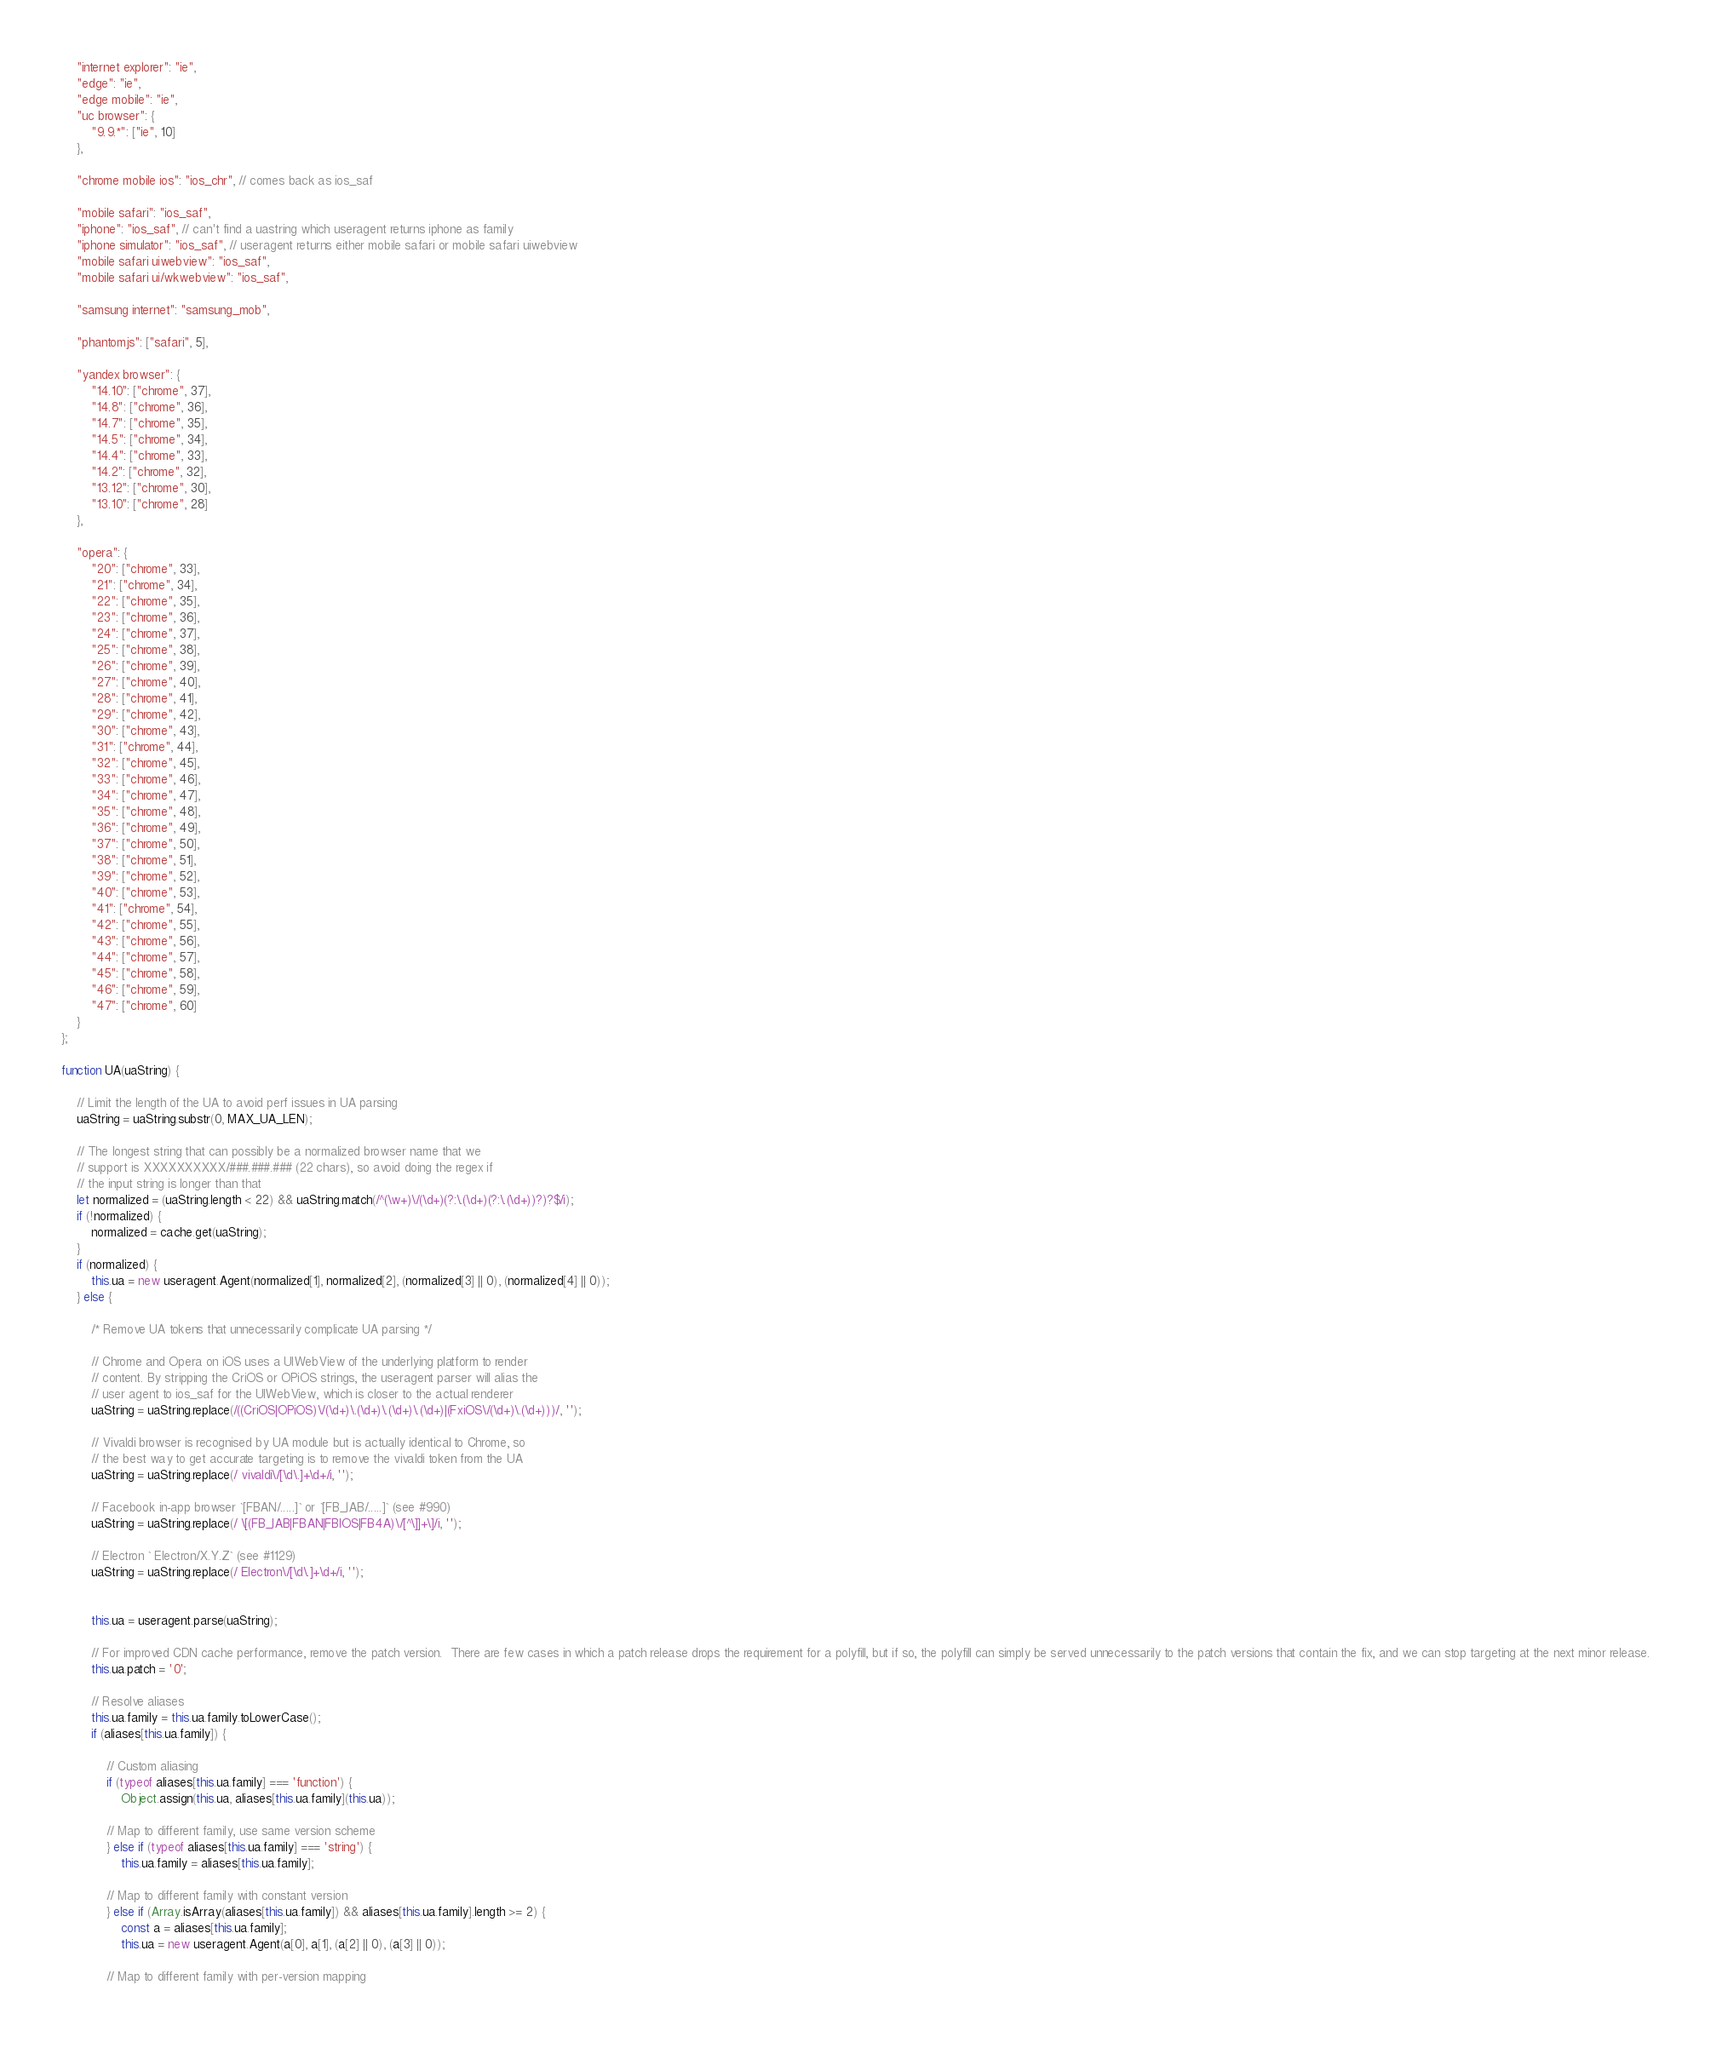<code> <loc_0><loc_0><loc_500><loc_500><_JavaScript_>	"internet explorer": "ie",
	"edge": "ie",
	"edge mobile": "ie",
	"uc browser": {
		"9.9.*": ["ie", 10]
	},

	"chrome mobile ios": "ios_chr", // comes back as ios_saf

	"mobile safari": "ios_saf",
	"iphone": "ios_saf", // can't find a uastring which useragent returns iphone as family
	"iphone simulator": "ios_saf", // useragent returns either mobile safari or mobile safari uiwebview
	"mobile safari uiwebview": "ios_saf",
	"mobile safari ui/wkwebview": "ios_saf",

	"samsung internet": "samsung_mob",

	"phantomjs": ["safari", 5],

	"yandex browser": {
		"14.10": ["chrome", 37],
		"14.8": ["chrome", 36],
		"14.7": ["chrome", 35],
		"14.5": ["chrome", 34],
		"14.4": ["chrome", 33],
		"14.2": ["chrome", 32],
		"13.12": ["chrome", 30],
		"13.10": ["chrome", 28]
	},

	"opera": {
		"20": ["chrome", 33],
		"21": ["chrome", 34],
		"22": ["chrome", 35],
		"23": ["chrome", 36],
		"24": ["chrome", 37],
		"25": ["chrome", 38],
		"26": ["chrome", 39],
		"27": ["chrome", 40],
		"28": ["chrome", 41],
		"29": ["chrome", 42],
		"30": ["chrome", 43],
		"31": ["chrome", 44],
		"32": ["chrome", 45],
		"33": ["chrome", 46],
		"34": ["chrome", 47],
		"35": ["chrome", 48],
		"36": ["chrome", 49],
		"37": ["chrome", 50],
		"38": ["chrome", 51],
		"39": ["chrome", 52],
		"40": ["chrome", 53],
		"41": ["chrome", 54],
		"42": ["chrome", 55],
		"43": ["chrome", 56],
		"44": ["chrome", 57],
		"45": ["chrome", 58],
		"46": ["chrome", 59],
		"47": ["chrome", 60]
	}
};

function UA(uaString) {

	// Limit the length of the UA to avoid perf issues in UA parsing
	uaString = uaString.substr(0, MAX_UA_LEN);

	// The longest string that can possibly be a normalized browser name that we
	// support is XXXXXXXXXX/###.###.### (22 chars), so avoid doing the regex if
	// the input string is longer than that
	let normalized = (uaString.length < 22) && uaString.match(/^(\w+)\/(\d+)(?:\.(\d+)(?:\.(\d+))?)?$/i);
	if (!normalized) {
		normalized = cache.get(uaString);
	}
	if (normalized) {
		this.ua = new useragent.Agent(normalized[1], normalized[2], (normalized[3] || 0), (normalized[4] || 0));
	} else {

		/* Remove UA tokens that unnecessarily complicate UA parsing */

		// Chrome and Opera on iOS uses a UIWebView of the underlying platform to render
		// content. By stripping the CriOS or OPiOS strings, the useragent parser will alias the
		// user agent to ios_saf for the UIWebView, which is closer to the actual renderer
		uaString = uaString.replace(/((CriOS|OPiOS)\/(\d+)\.(\d+)\.(\d+)\.(\d+)|(FxiOS\/(\d+)\.(\d+)))/, '');

		// Vivaldi browser is recognised by UA module but is actually identical to Chrome, so
		// the best way to get accurate targeting is to remove the vivaldi token from the UA
		uaString = uaString.replace(/ vivaldi\/[\d\.]+\d+/i, '');

		// Facebook in-app browser `[FBAN/.....]` or `[FB_IAB/.....]` (see #990)
		uaString = uaString.replace(/ \[(FB_IAB|FBAN|FBIOS|FB4A)\/[^\]]+\]/i, '');

		// Electron ` Electron/X.Y.Z` (see #1129)
		uaString = uaString.replace(/ Electron\/[\d\.]+\d+/i, '');


		this.ua = useragent.parse(uaString);

		// For improved CDN cache performance, remove the patch version.  There are few cases in which a patch release drops the requirement for a polyfill, but if so, the polyfill can simply be served unnecessarily to the patch versions that contain the fix, and we can stop targeting at the next minor release.
		this.ua.patch = '0';

		// Resolve aliases
		this.ua.family = this.ua.family.toLowerCase();
		if (aliases[this.ua.family]) {

			// Custom aliasing
			if (typeof aliases[this.ua.family] === 'function') {
				Object.assign(this.ua, aliases[this.ua.family](this.ua));

			// Map to different family, use same version scheme
			} else if (typeof aliases[this.ua.family] === 'string') {
				this.ua.family = aliases[this.ua.family];

			// Map to different family with constant version
			} else if (Array.isArray(aliases[this.ua.family]) && aliases[this.ua.family].length >= 2) {
				const a = aliases[this.ua.family];
				this.ua = new useragent.Agent(a[0], a[1], (a[2] || 0), (a[3] || 0));

			// Map to different family with per-version mapping</code> 